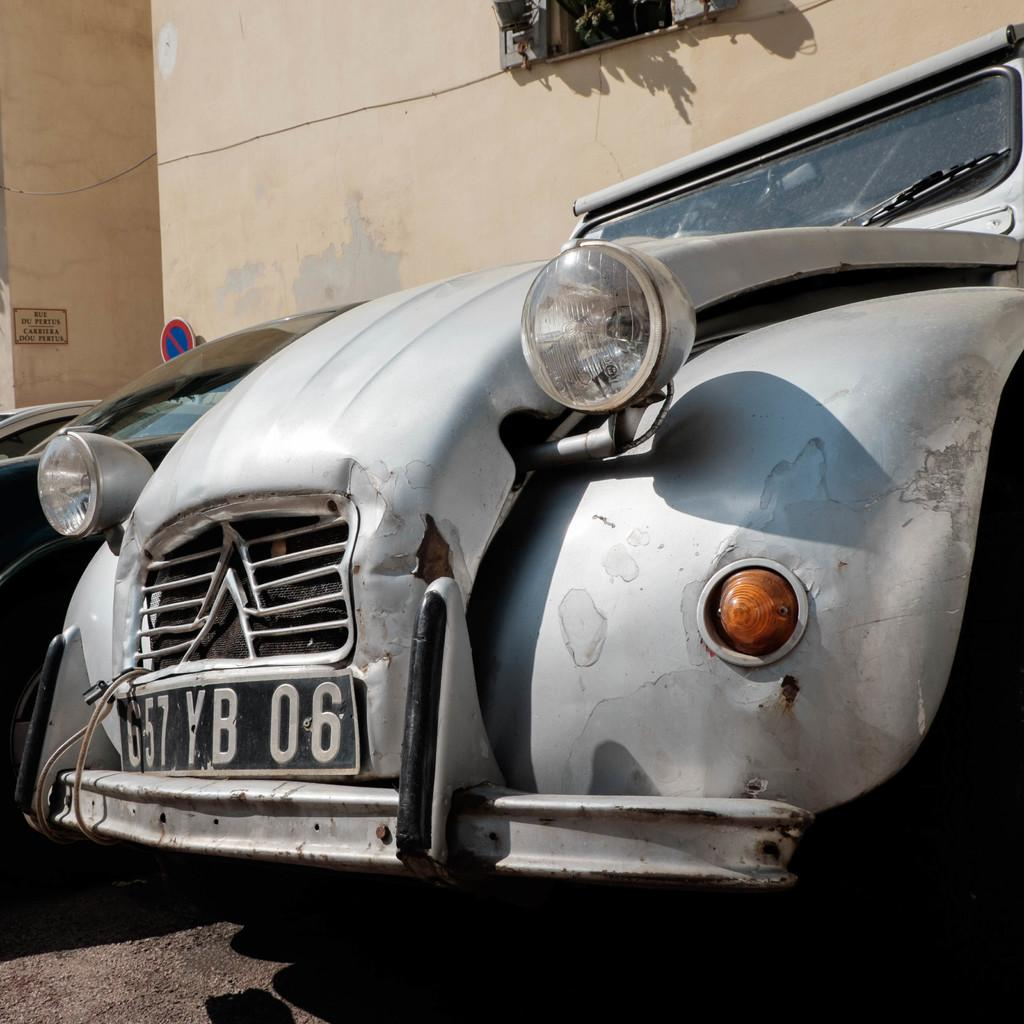How many cars can be seen on the road in the image? There are two cars on the road in the image. What is located in the background of the image? There is a signboard and a board attached to a wall in the background of the image. Can you describe the window visible in the image? There is a window visible at the top of the image. What type of heart can be seen beating in the image? There is no heart visible in the image. 